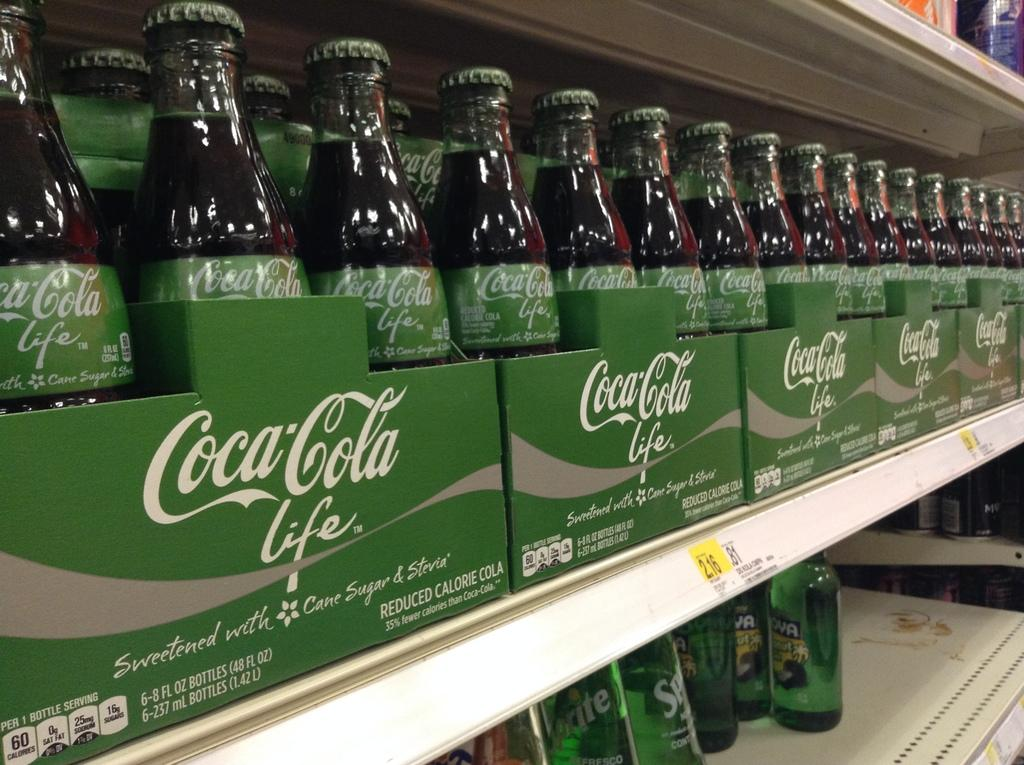What type of storage units are present in the image? There are racks in the image. What items can be found on the racks? The racks contain soft drink bottles. Can you identify any specific brand of soft drink bottles in the image? Yes, there are Coca-Cola bottles in the center of the image. Are there any whistles visible on the edge of the racks in the image? No, there are no whistles present in the image. Can you see any fairies flying around the soft drink bottles in the image? No, there are no fairies present in the image. 